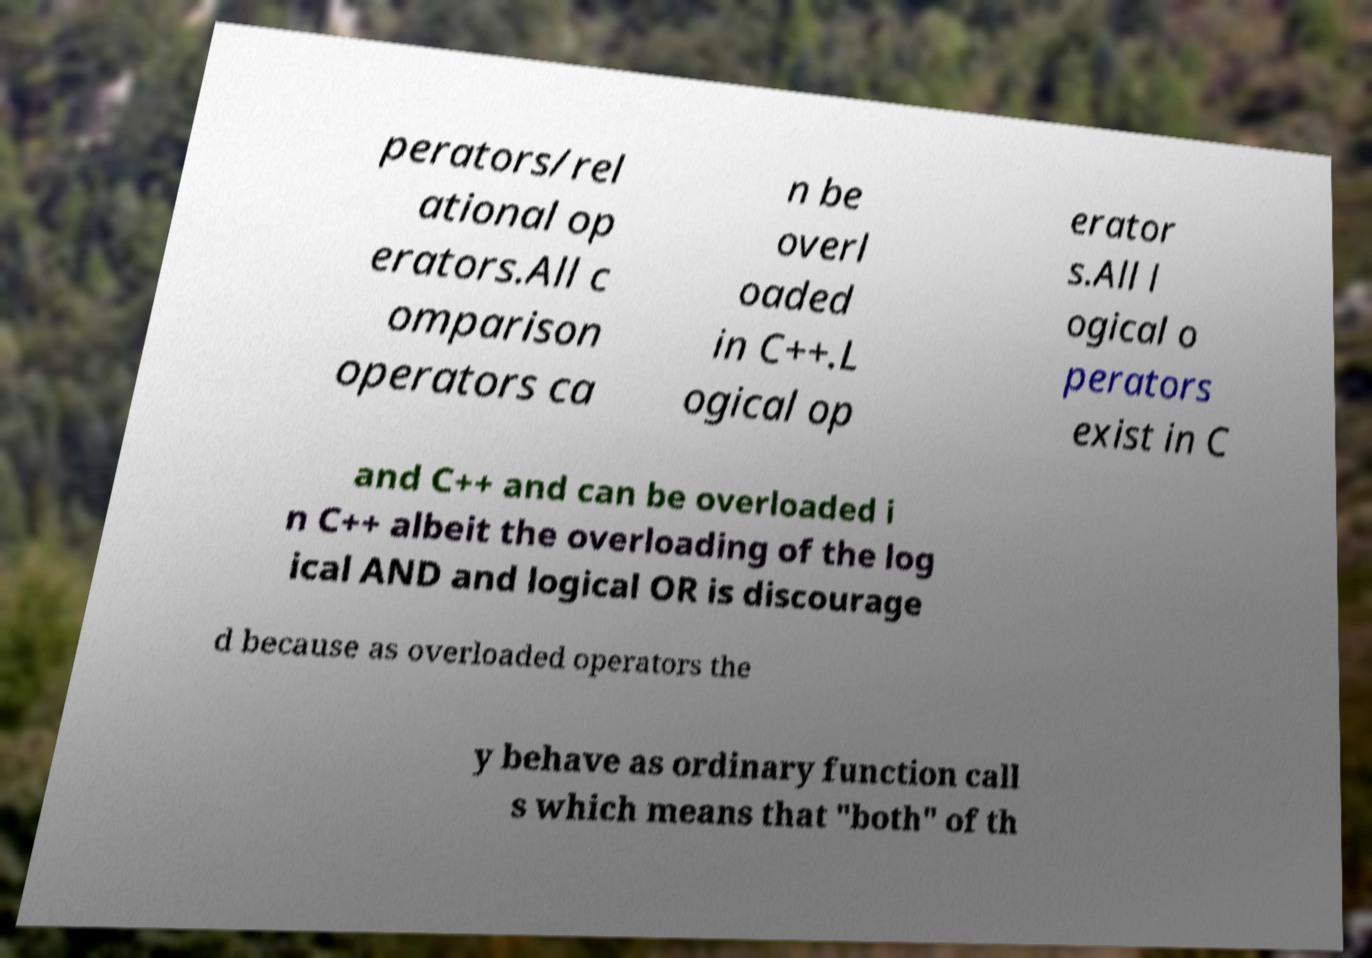Please read and relay the text visible in this image. What does it say? perators/rel ational op erators.All c omparison operators ca n be overl oaded in C++.L ogical op erator s.All l ogical o perators exist in C and C++ and can be overloaded i n C++ albeit the overloading of the log ical AND and logical OR is discourage d because as overloaded operators the y behave as ordinary function call s which means that "both" of th 